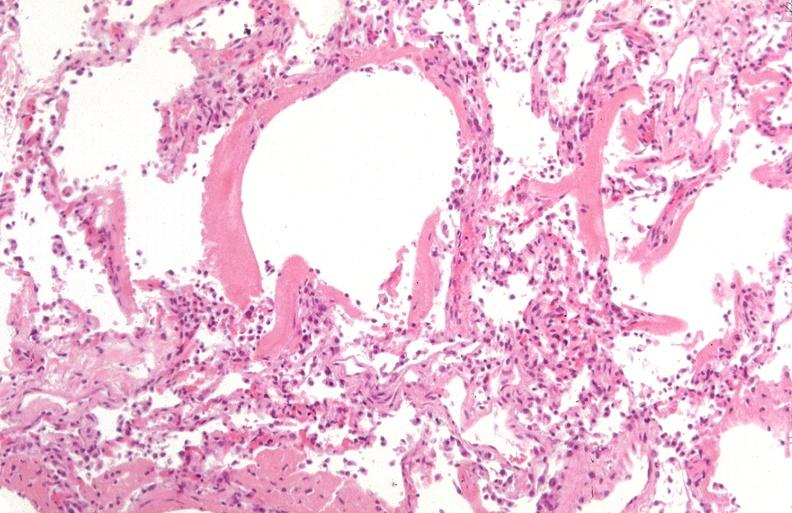does this image show lung?
Answer the question using a single word or phrase. Yes 